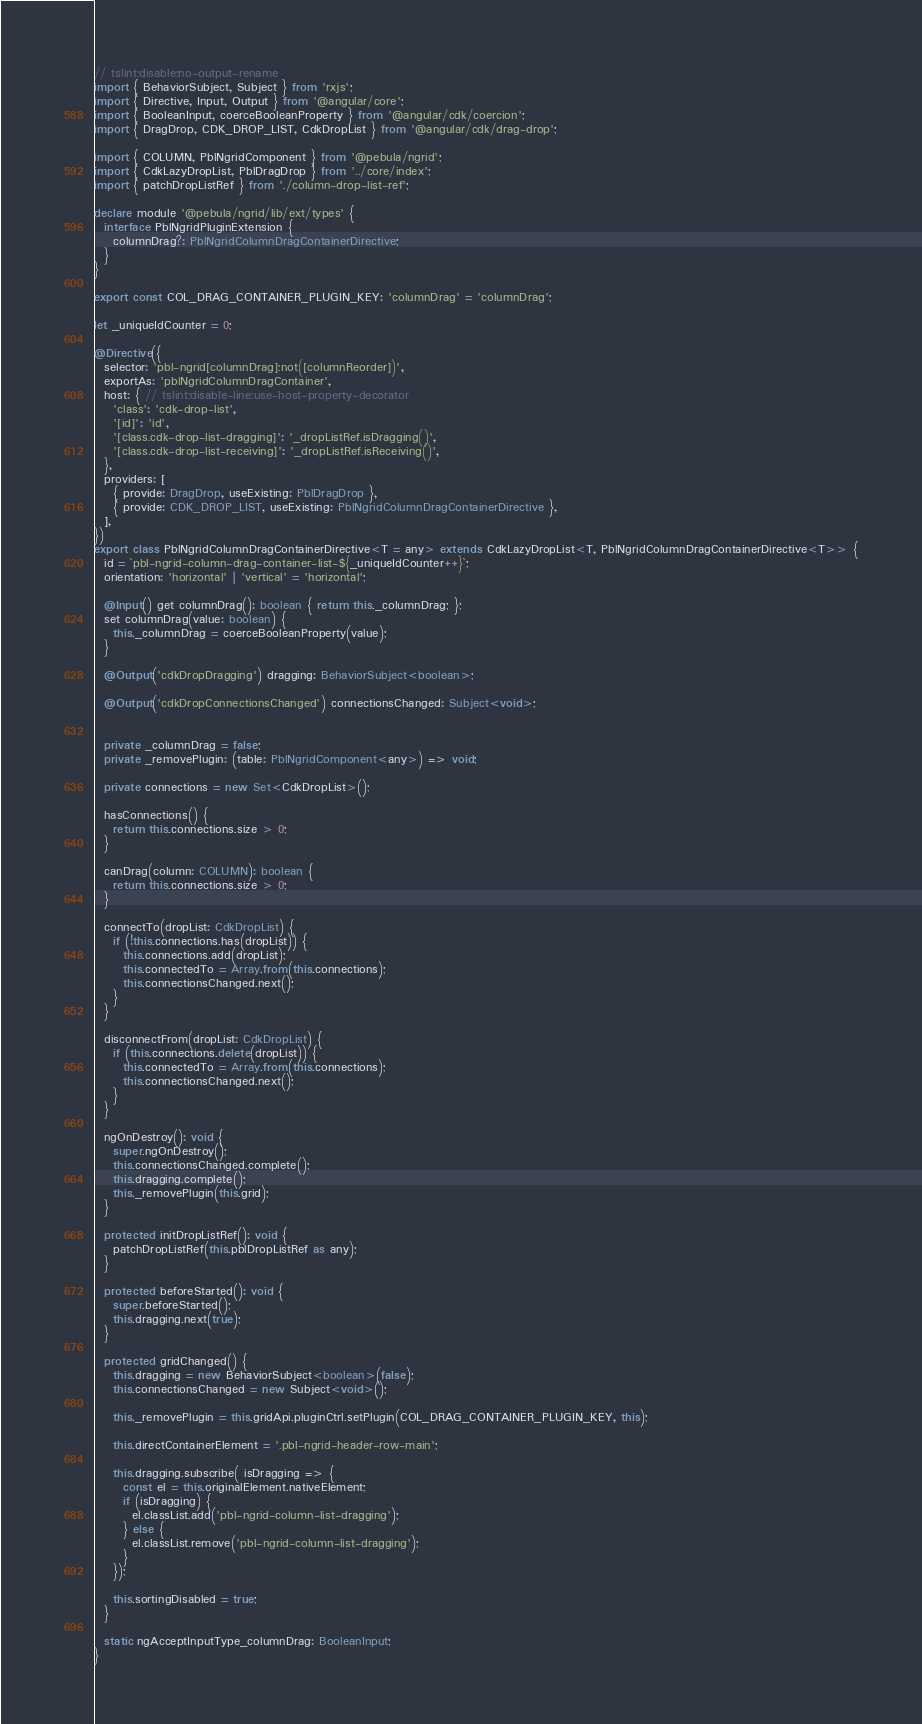<code> <loc_0><loc_0><loc_500><loc_500><_TypeScript_>// tslint:disable:no-output-rename
import { BehaviorSubject, Subject } from 'rxjs';
import { Directive, Input, Output } from '@angular/core';
import { BooleanInput, coerceBooleanProperty } from '@angular/cdk/coercion';
import { DragDrop, CDK_DROP_LIST, CdkDropList } from '@angular/cdk/drag-drop';

import { COLUMN, PblNgridComponent } from '@pebula/ngrid';
import { CdkLazyDropList, PblDragDrop } from '../core/index';
import { patchDropListRef } from './column-drop-list-ref';

declare module '@pebula/ngrid/lib/ext/types' {
  interface PblNgridPluginExtension {
    columnDrag?: PblNgridColumnDragContainerDirective;
  }
}

export const COL_DRAG_CONTAINER_PLUGIN_KEY: 'columnDrag' = 'columnDrag';

let _uniqueIdCounter = 0;

@Directive({
  selector: 'pbl-ngrid[columnDrag]:not([columnReorder])',
  exportAs: 'pblNgridColumnDragContainer',
  host: { // tslint:disable-line:use-host-property-decorator
    'class': 'cdk-drop-list',
    '[id]': 'id',
    '[class.cdk-drop-list-dragging]': '_dropListRef.isDragging()',
    '[class.cdk-drop-list-receiving]': '_dropListRef.isReceiving()',
  },
  providers: [
    { provide: DragDrop, useExisting: PblDragDrop },
    { provide: CDK_DROP_LIST, useExisting: PblNgridColumnDragContainerDirective },
  ],
})
export class PblNgridColumnDragContainerDirective<T = any> extends CdkLazyDropList<T, PblNgridColumnDragContainerDirective<T>> {
  id = `pbl-ngrid-column-drag-container-list-${_uniqueIdCounter++}`;
  orientation: 'horizontal' | 'vertical' = 'horizontal';

  @Input() get columnDrag(): boolean { return this._columnDrag; };
  set columnDrag(value: boolean) {
    this._columnDrag = coerceBooleanProperty(value);
  }

  @Output('cdkDropDragging') dragging: BehaviorSubject<boolean>;

  @Output('cdkDropConnectionsChanged') connectionsChanged: Subject<void>;


  private _columnDrag = false;
  private _removePlugin: (table: PblNgridComponent<any>) => void;

  private connections = new Set<CdkDropList>();

  hasConnections() {
    return this.connections.size > 0;
  }

  canDrag(column: COLUMN): boolean {
    return this.connections.size > 0;
  }

  connectTo(dropList: CdkDropList) {
    if (!this.connections.has(dropList)) {
      this.connections.add(dropList);
      this.connectedTo = Array.from(this.connections);
      this.connectionsChanged.next();
    }
  }

  disconnectFrom(dropList: CdkDropList) {
    if (this.connections.delete(dropList)) {
      this.connectedTo = Array.from(this.connections);
      this.connectionsChanged.next();
    }
  }

  ngOnDestroy(): void {
    super.ngOnDestroy();
    this.connectionsChanged.complete();
    this.dragging.complete();
    this._removePlugin(this.grid);
  }

  protected initDropListRef(): void {
    patchDropListRef(this.pblDropListRef as any);
  }

  protected beforeStarted(): void {
    super.beforeStarted();
    this.dragging.next(true);
  }

  protected gridChanged() {
    this.dragging = new BehaviorSubject<boolean>(false);
    this.connectionsChanged = new Subject<void>();

    this._removePlugin = this.gridApi.pluginCtrl.setPlugin(COL_DRAG_CONTAINER_PLUGIN_KEY, this);

    this.directContainerElement = '.pbl-ngrid-header-row-main';

    this.dragging.subscribe( isDragging => {
      const el = this.originalElement.nativeElement;
      if (isDragging) {
        el.classList.add('pbl-ngrid-column-list-dragging');
      } else {
        el.classList.remove('pbl-ngrid-column-list-dragging');
      }
    });

    this.sortingDisabled = true;
  }

  static ngAcceptInputType_columnDrag: BooleanInput;
}
</code> 